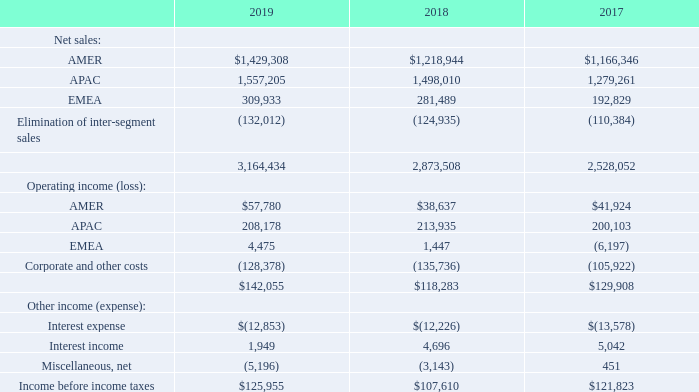11. Reportable Segments, Geographic Information and Major Customers
Reportable segments are defined as components of an enterprise about which separate financial information is available that is evaluated regularly by the chief operating decision maker, or group, in assessing performance and allocating resources. The Company uses an internal management reporting system, which provides important financial data to evaluate performance and allocate the Company’s resources on a regional basis. Net sales for the segments are attributed to the region in which the product is manufactured or the service is performed. The services provided, manufacturing processes used, class of customers serviced and order fulfillment processes used are similar and generally interchangeable across the segments. A segment’s performance is evaluated based upon its operating income (loss). A segment’s operating income (loss) includes its net sales less cost of sales and selling and administrative expenses, but excludes corporate and other expenses. Corporate and other expenses  fiscal 2019 and the $13.5 million one-time employee bonus paid to full-time, non-executive employees during fiscal 2018 due to the Company's ability to access overseas cash as a result of Tax Reform (the "one-time employee bonus"). These costs are not allocated to the segments, as management excludes such costs when assessing the performance of the segments. Inter-segment transactions are generally recorded at amounts that approximate arm’s length transactions. The accounting policies for the segments are the same as for the Company taken as a whole.
Information about the Company’s three reportable segments for fiscal 2019, 2018 and 2017 is as follows (in thousands):
What was the net sales from AMER in 2017?
Answer scale should be: thousand. 1,166,346. What was the total net sales in 2019?
Answer scale should be: thousand. 3,164,434. Which years does the table provide information for its reportable segments? 2019, 2018, 2017. How many years did the net sales from EMEA exceed $300,000 thousand? 2019
Answer: 1. What was the change in the net sales from APAC between 2017 and 2018?
Answer scale should be: thousand. 1,498,010-1,279,261
Answer: 218749. What was the percentage change in the total net sales between 2018 and 2019?
Answer scale should be: percent. (3,164,434-2,873,508)/2,873,508
Answer: 10.12. 